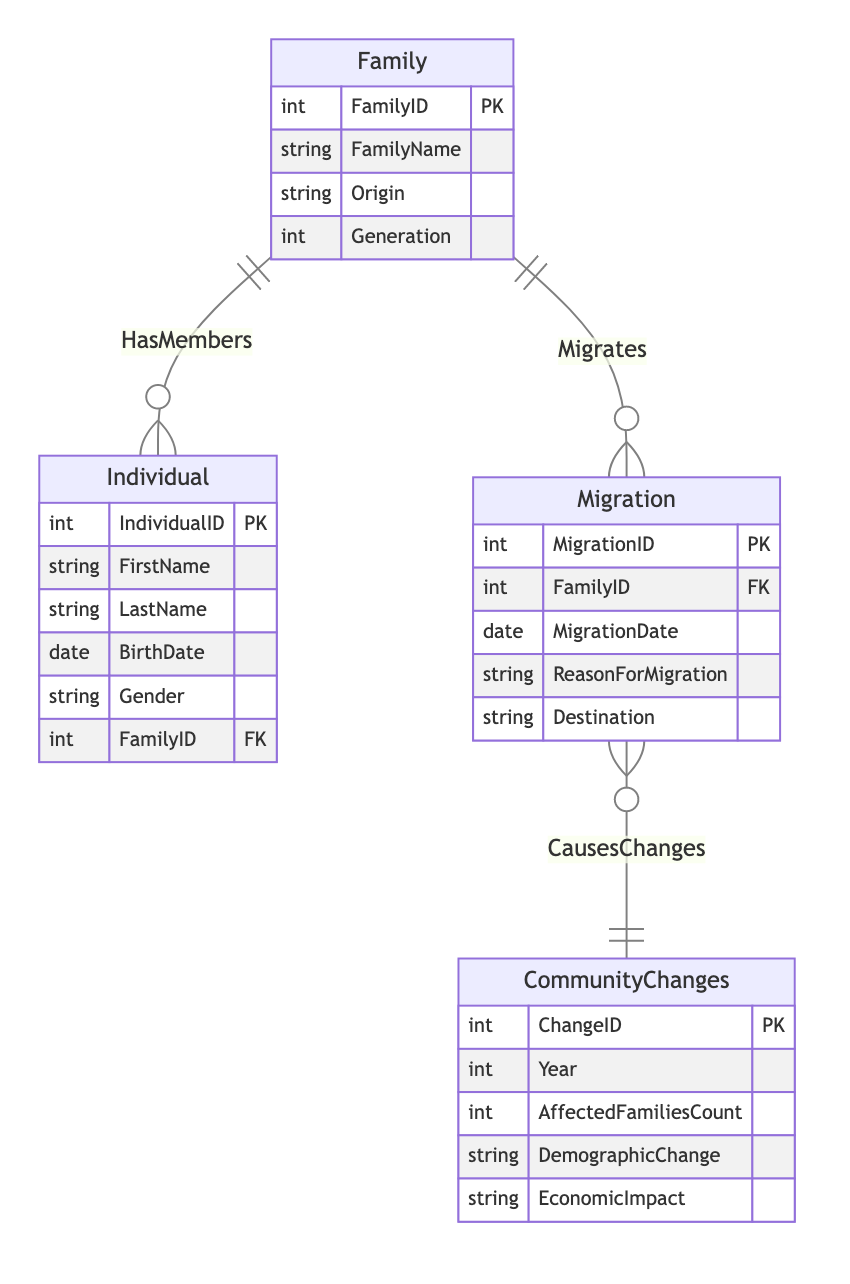what is the primary key of the Family entity? The primary key of the Family entity is FamilyID, denoted by "PK" next to it in the diagram.
Answer: FamilyID how many attributes does the Migration entity have? The Migration entity has four attributes: MigrationID, FamilyID, MigrationDate, and ReasonForMigration. Therefore, the count is four.
Answer: 4 what is the relationship type between Family and Individual? The relationship type between Family and Individual is modeled as "1 to Many," meaning one Family can have multiple Individual members associated with it.
Answer: 1 to Many which entity has a foreign key named FamilyID? The Individual and Migration entities both include a foreign key named FamilyID, which points to the Family entity.
Answer: Individual, Migration how many relationships are there in this diagram? The diagram features three relationships: HasMembers, Migrates, and CausesChanges. Counting these gives a total of three relationships.
Answer: 3 what does the Migration entity cause in the CommunityChanges entity? The Migration entity causes changes represented within the CommunityChanges entity, specifically noted with the relationship "CausesChanges." This indicates a connection where migrations lead to community changes.
Answer: Changes which entity can have multiple corresponding migration records? The Family entity can have multiple corresponding migration records since it has a "1 to Many" relationship with the Migration entity.
Answer: Family how many total entities are in the diagram? There are four entities in the diagram: Family, Individual, Migration, and CommunityChanges. Counting these gives a total of four entities.
Answer: 4 what type of changes does the CommunityChanges entity describe? The CommunityChanges entity describes demographic changes and economic impacts that occur due to migrations, indicated by its attributes.
Answer: Changes what is the primary key of the CommunityChanges entity? The primary key of the CommunityChanges entity is ChangeID, as indicated by "PK" next to it in the entity definition.
Answer: ChangeID 